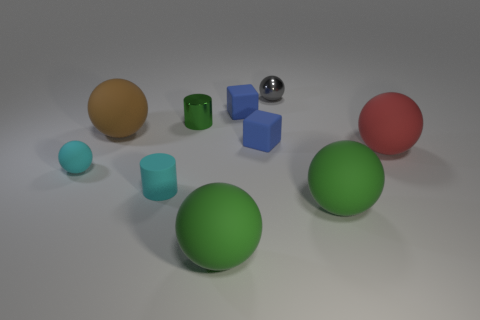Subtract all tiny gray balls. How many balls are left? 5 Subtract 6 spheres. How many spheres are left? 0 Subtract all cyan cylinders. How many cylinders are left? 1 Subtract all cubes. How many objects are left? 8 Subtract all green blocks. How many yellow spheres are left? 0 Add 3 small matte balls. How many small matte balls are left? 4 Add 9 large cyan metallic blocks. How many large cyan metallic blocks exist? 9 Subtract 2 blue blocks. How many objects are left? 8 Subtract all red cylinders. Subtract all brown blocks. How many cylinders are left? 2 Subtract all cyan matte cylinders. Subtract all tiny red metal balls. How many objects are left? 9 